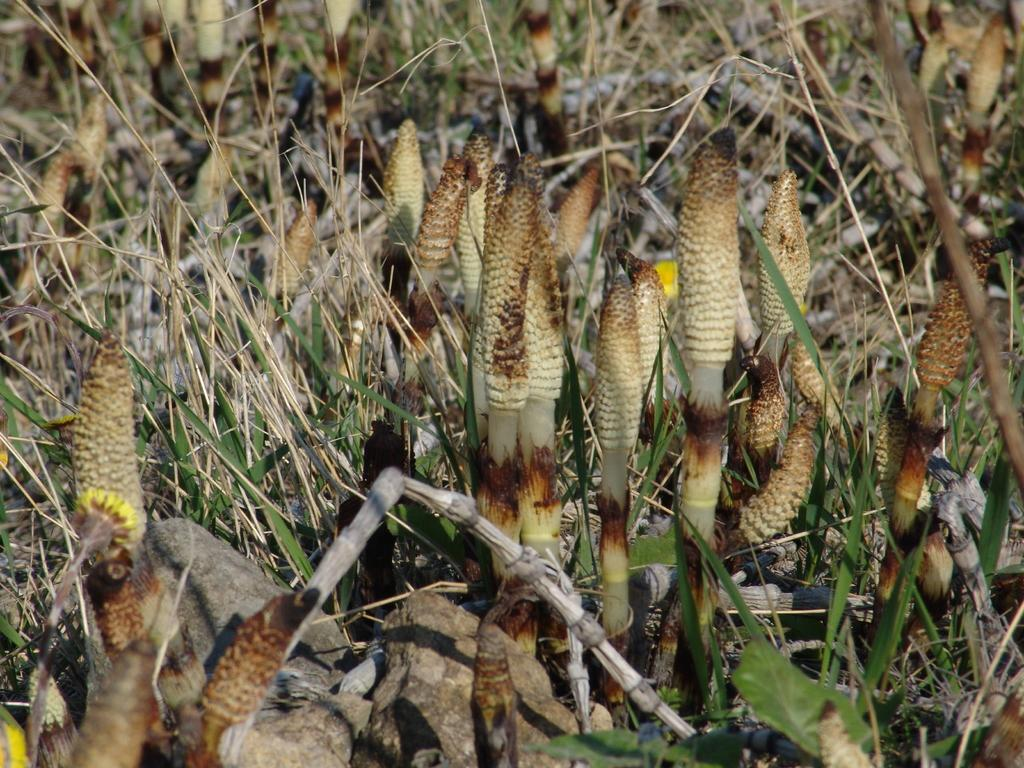What is the main subject of the image? The main subject of the image is a group of plants. Can you describe the plants in the image? Unfortunately, the facts provided do not give any specific details about the plants. Are there any other objects or elements in the image besides the plants? The facts provided do not mention any other objects or elements in the image. What type of vessel can be seen sailing through the waves in the image? There is no vessel or waves present in the image; it features a group of plants. 